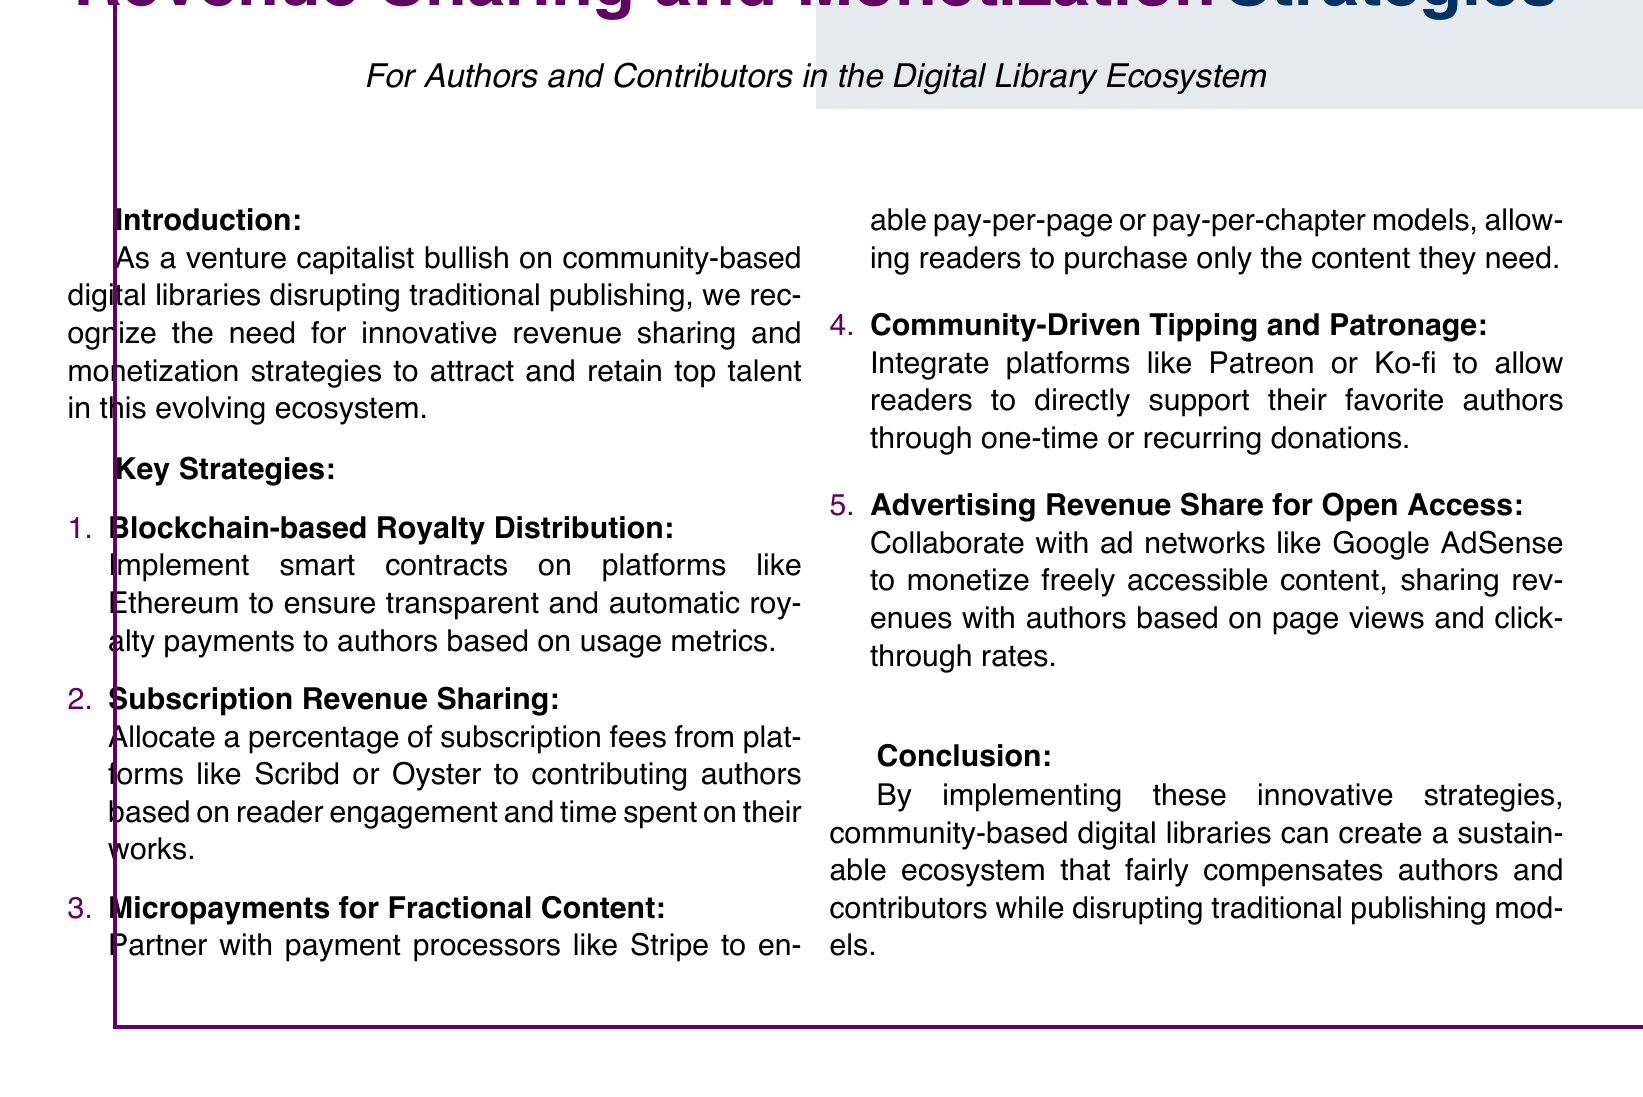What is the main focus of the document? The main focus of the document is on revenue sharing and monetization strategies for authors and contributors in the digital library ecosystem.
Answer: Revenue sharing and monetization strategies How many key strategies are listed? The document explicitly states the number of strategies in the "Key Strategies" section, which is 5.
Answer: 5 What is the first strategy mentioned? The document lists the first strategy under "Key Strategies" as blockchain-based royalty distribution.
Answer: Blockchain-based Royalty Distribution Which payment processor is mentioned for micropayments? The document names Stripe as the payment processor for enabling micropayments.
Answer: Stripe What collaboration is suggested for open access advertising revenue? The document suggests collaborating with Google AdSense for monetizing open access content.
Answer: Google AdSense What is the title of the document? The title of the document is prominently displayed at the top, indicating the subject matter related to revenue and strategies.
Answer: Revenue Sharing and Monetization Strategies What type of licenses should the ecosystem encourage? Implicitly, the document suggests creating a sustainable ecosystem that fairly compensates authors, hinting at encouraging open licenses.
Answer: Open licenses What type of donations does the document propose for community-driven support? The document proposes allowing either one-time or recurring donations for community-driven support of authors.
Answer: One-time or recurring donations 